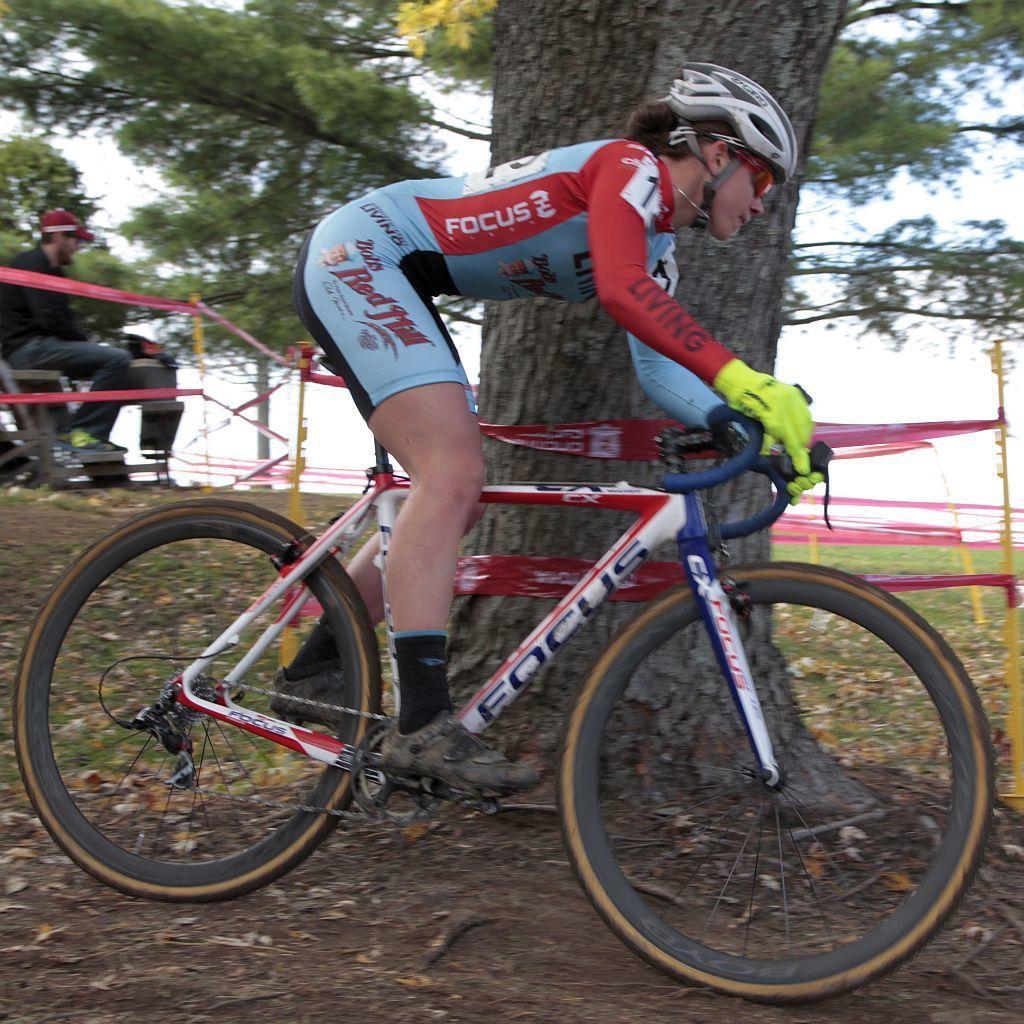Can you describe this image briefly? In the middle of this image, there is a person wearing a helmet and light green color gloves and cycling on the ground. Beside this person, there is a tree. In the background, there are pink color ribbons attached to the poles, there is a person sitting, there are trees and there is sky. 